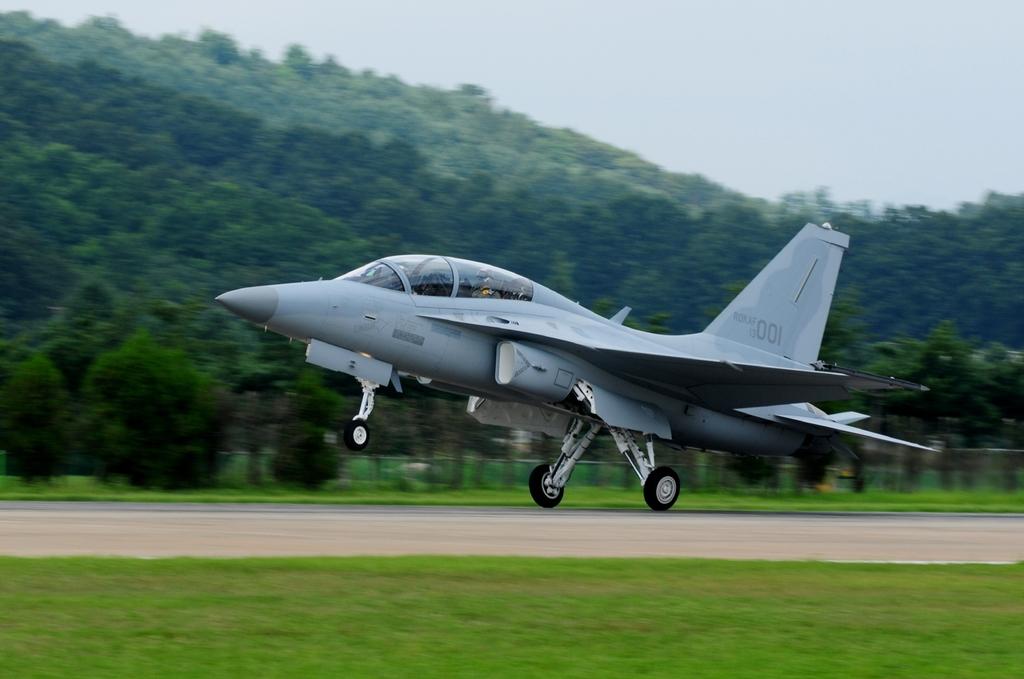What number is on the tail of the plane?
Your response must be concise. 001. 